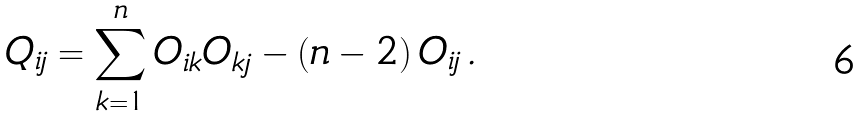Convert formula to latex. <formula><loc_0><loc_0><loc_500><loc_500>Q _ { i j } = \sum _ { k = 1 } ^ { n } O _ { i k } O _ { k j } - ( n - 2 ) \, O _ { i j } \, .</formula> 